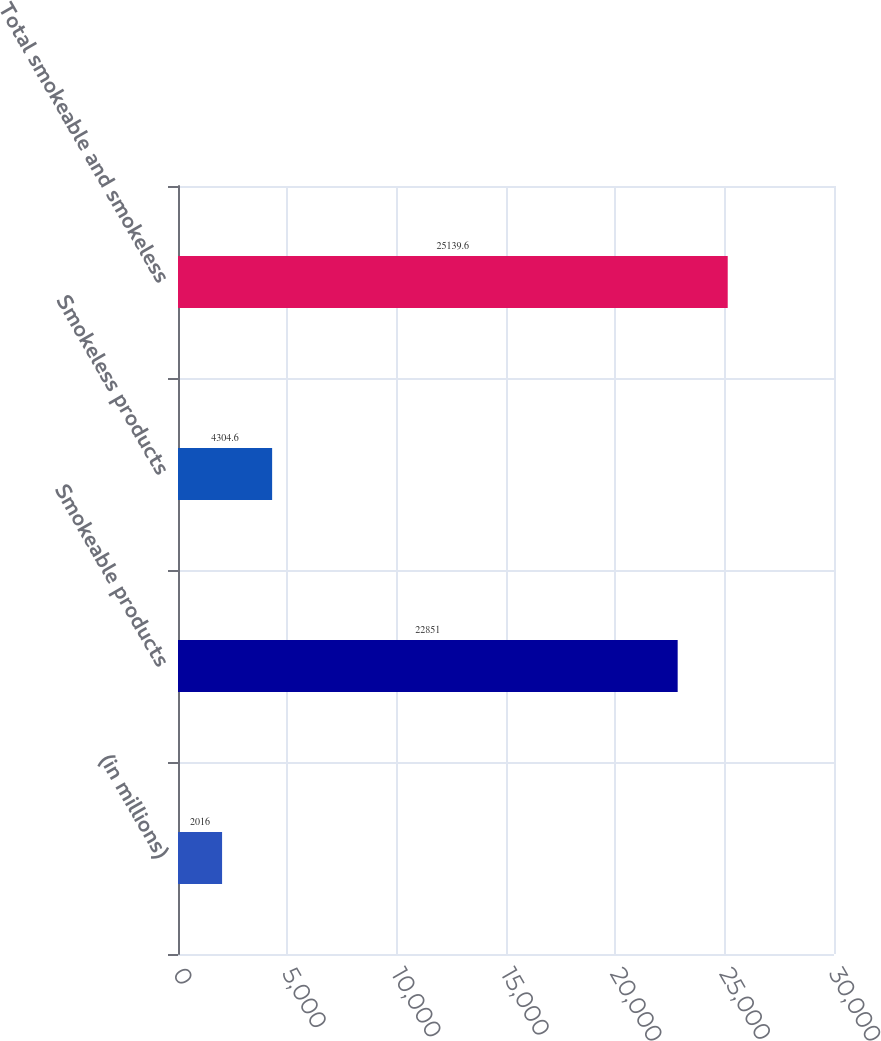<chart> <loc_0><loc_0><loc_500><loc_500><bar_chart><fcel>(in millions)<fcel>Smokeable products<fcel>Smokeless products<fcel>Total smokeable and smokeless<nl><fcel>2016<fcel>22851<fcel>4304.6<fcel>25139.6<nl></chart> 